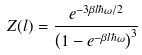<formula> <loc_0><loc_0><loc_500><loc_500>Z ( l ) = \frac { e ^ { - 3 \beta l \hbar { \omega } / 2 } } { \left ( 1 - e ^ { - \beta l \hbar { \omega } } \right ) ^ { 3 } }</formula> 